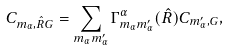Convert formula to latex. <formula><loc_0><loc_0><loc_500><loc_500>C _ { m _ { \alpha } , \hat { R } { G } } & = \sum _ { m _ { \alpha } m ^ { \prime } _ { \alpha } } \Gamma ^ { \alpha } _ { m _ { \alpha } m ^ { \prime } _ { \alpha } } ( \hat { R } ) C _ { m ^ { \prime } _ { \alpha } , { G } } ,</formula> 